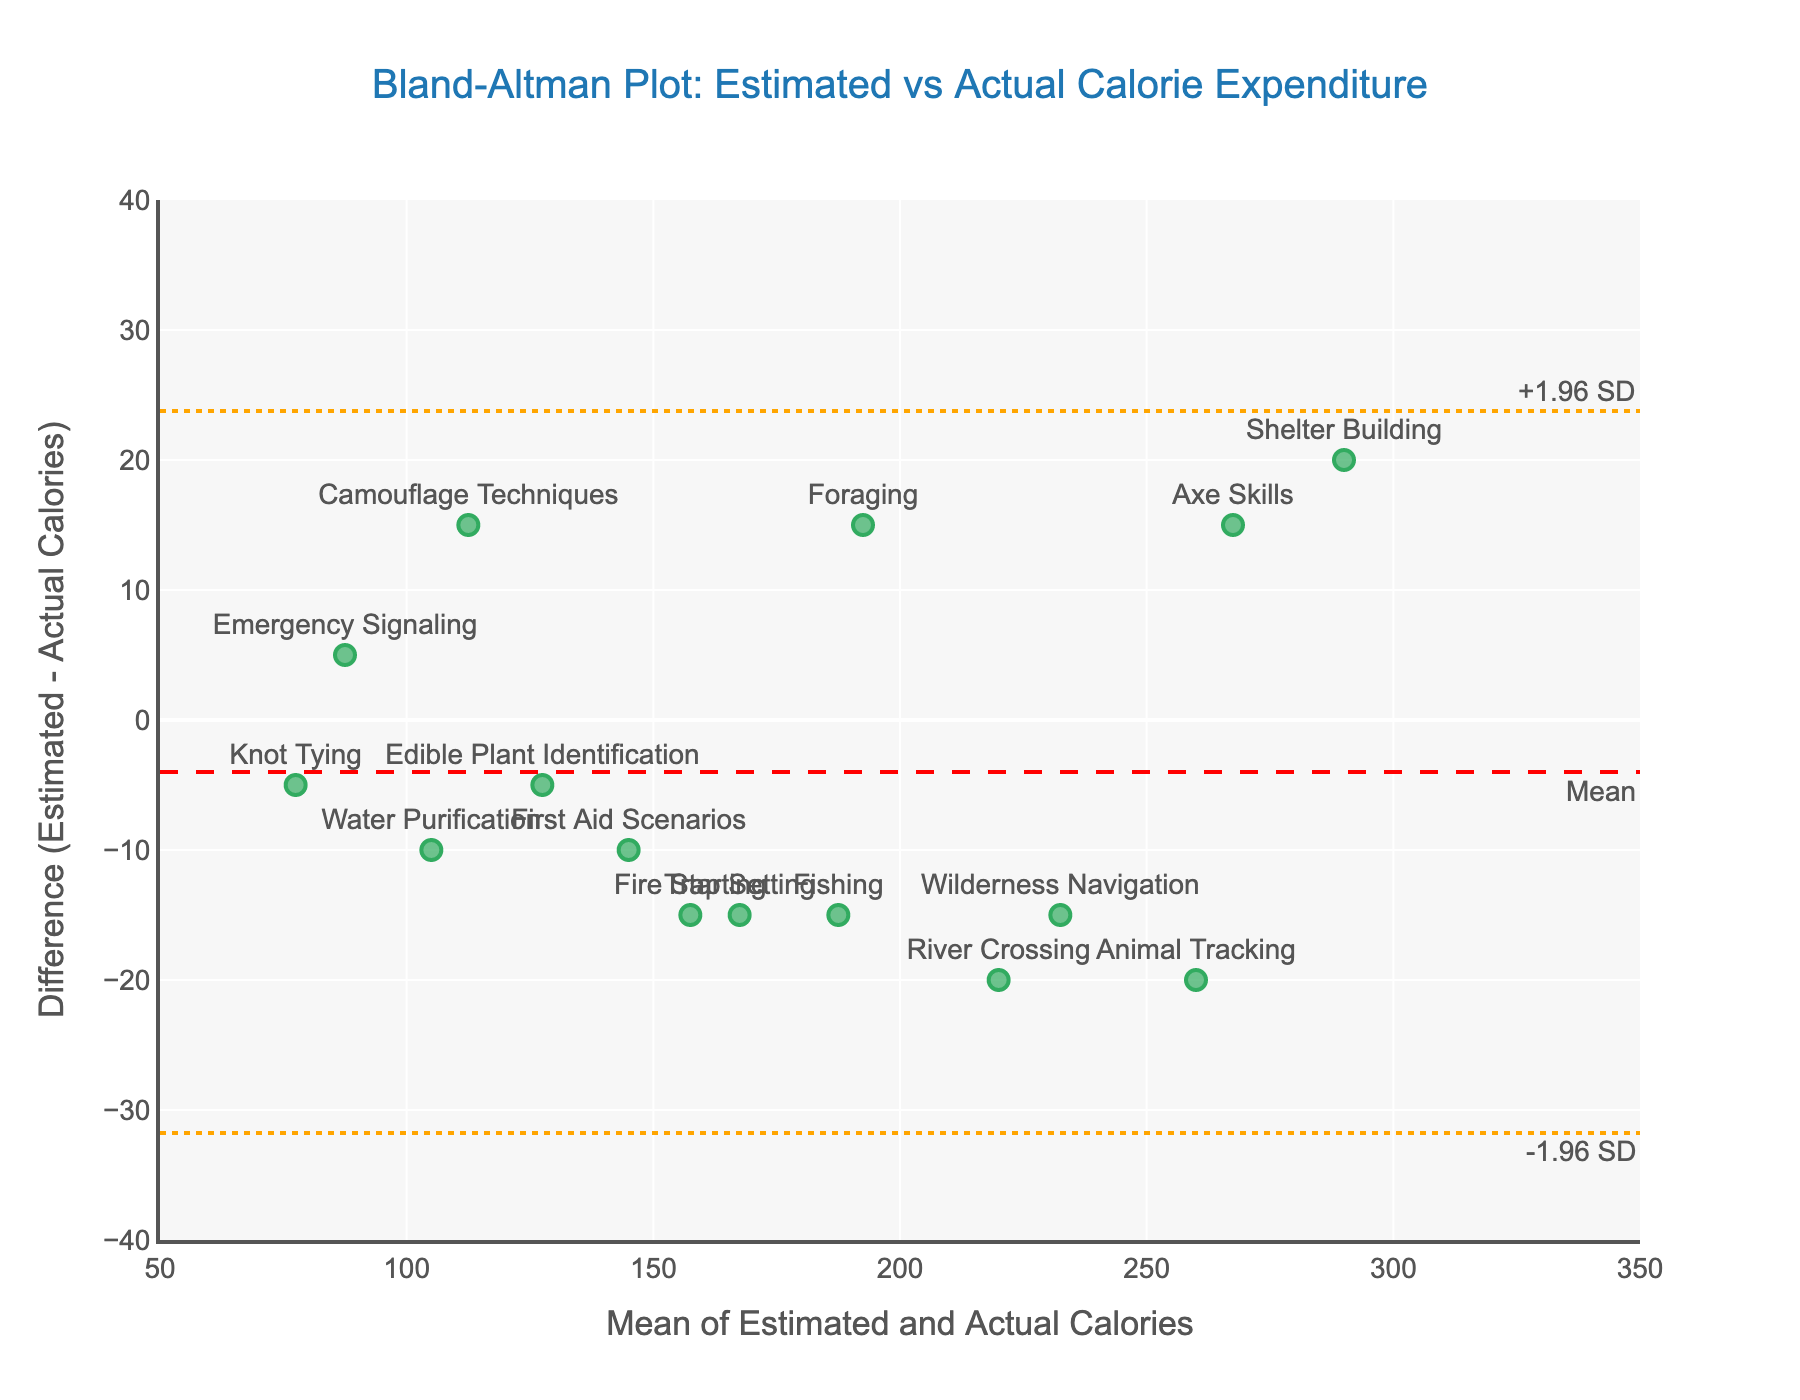What is the title of the plot? The title of the plot can be found at the top center of the figure. It reads "Bland-Altman Plot: Estimated vs Actual Calorie Expenditure".
Answer: Bland-Altman Plot: Estimated vs Actual Calorie Expenditure Which exercise has the largest positive difference between estimated and actual calories? By examining the y-values (differences) for each exercise, the point with the highest positive y-value represents the largest positive difference. "Fire Starting" has the largest positive difference at 15.
Answer: Fire Starting How many exercises have a negative difference between estimated and actual calories? Locate the points below the horizontal axis (y=0) as they represent negative differences. Count these points: Shelter Building, Animal Tracking, Wilderness Navigation, River Crossing, Camouflage Techniques, Trap Setting. There are six points.
Answer: 6 What is the range of mean values for the exercises shown in the plot? The range of mean values is determined by the x-axis, which represents the mean of estimated and actual calories. The lowest value is around 80 and the highest is around 275.
Answer: 80 to 275 Which exercise has the smallest mean difference from the actual calories? The smallest mean difference corresponds to the point closest to the horizontal red dashed line (mean line). "Emergency Signaling" has the smallest mean difference.
Answer: Emergency Signaling What are the upper and lower limits of agreement in the plot? Identify the y-values where the orange dashed lines are located. These lines represent the limits of agreement. The lower limit (bottom orange line) is approximately -32.8, and the upper limit (top orange line) is approximately 30.4.
Answer: -32.8 and 30.4 How many exercises fall outside the limits of agreement? Points outside the orange dashed lines lie outside the limits of agreement. Identify such points: there is one point above the upper limit (Animal Tracking) and one point below the lower limit line (Camouflage Techniques).
Answer: 2 Which exercise has the largest absolute difference between estimated and actual calorie expenditure? Find the point with the greatest distance from the horizontal line (regardless of positive or negative): "Animal Tracking" with a difference of -20 calories and "River Crossing" with a difference of -20 calories can be considered.
Answer: Animal Tracking and River Crossing On average, are the estimated calories higher or lower than the actual calories? The average difference lines and their position relative to 0 on the y-axis will give this information. Since the mean line is slightly below zero, on average, the estimated calories are lower.
Answer: Lower 